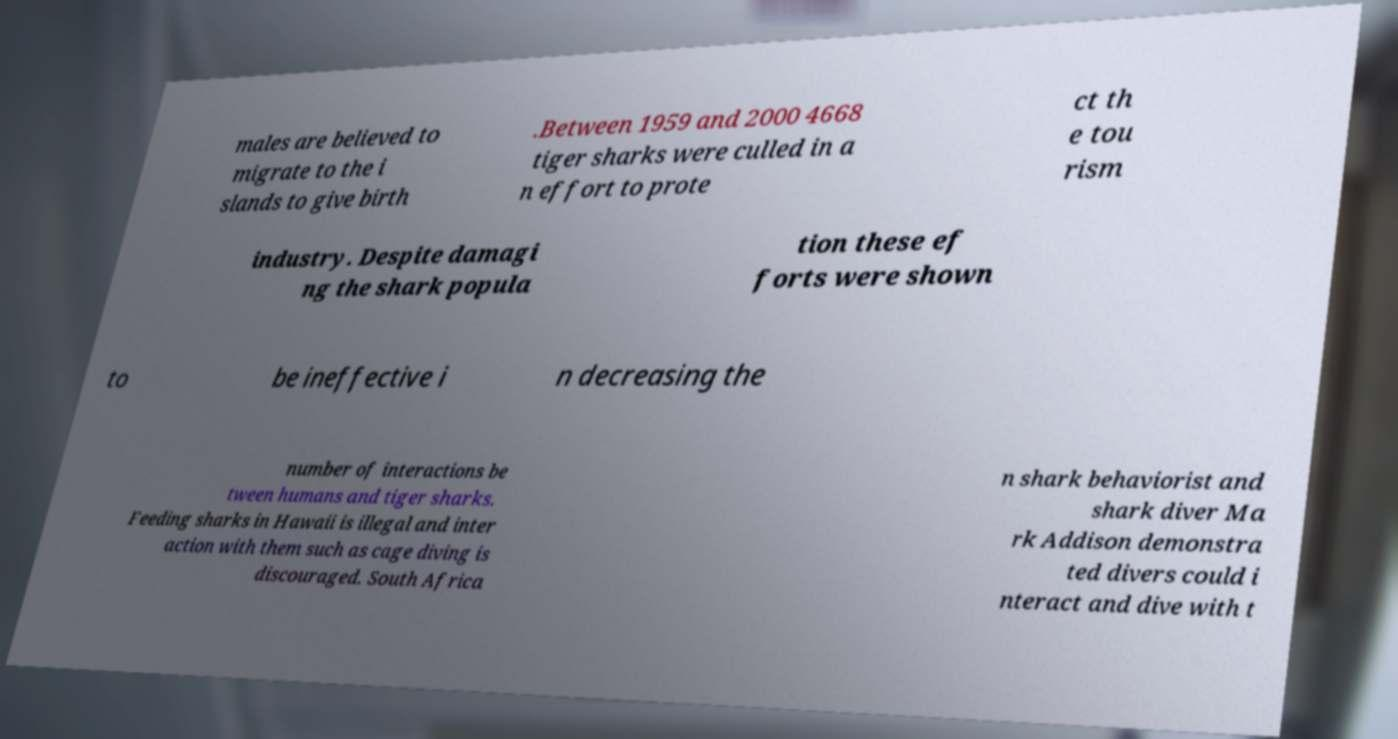What messages or text are displayed in this image? I need them in a readable, typed format. males are believed to migrate to the i slands to give birth .Between 1959 and 2000 4668 tiger sharks were culled in a n effort to prote ct th e tou rism industry. Despite damagi ng the shark popula tion these ef forts were shown to be ineffective i n decreasing the number of interactions be tween humans and tiger sharks. Feeding sharks in Hawaii is illegal and inter action with them such as cage diving is discouraged. South Africa n shark behaviorist and shark diver Ma rk Addison demonstra ted divers could i nteract and dive with t 